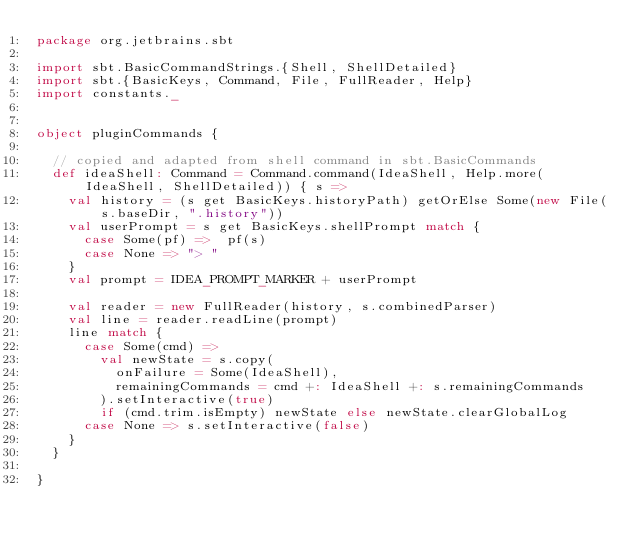<code> <loc_0><loc_0><loc_500><loc_500><_Scala_>package org.jetbrains.sbt

import sbt.BasicCommandStrings.{Shell, ShellDetailed}
import sbt.{BasicKeys, Command, File, FullReader, Help}
import constants._


object pluginCommands {

  // copied and adapted from shell command in sbt.BasicCommands
  def ideaShell: Command = Command.command(IdeaShell, Help.more(IdeaShell, ShellDetailed)) { s =>
    val history = (s get BasicKeys.historyPath) getOrElse Some(new File(s.baseDir, ".history"))
    val userPrompt = s get BasicKeys.shellPrompt match {
      case Some(pf) =>  pf(s)
      case None => "> "
    }
    val prompt = IDEA_PROMPT_MARKER + userPrompt

    val reader = new FullReader(history, s.combinedParser)
    val line = reader.readLine(prompt)
    line match {
      case Some(cmd) =>
        val newState = s.copy(
          onFailure = Some(IdeaShell),
          remainingCommands = cmd +: IdeaShell +: s.remainingCommands
        ).setInteractive(true)
        if (cmd.trim.isEmpty) newState else newState.clearGlobalLog
      case None => s.setInteractive(false)
    }
  }

}
</code> 